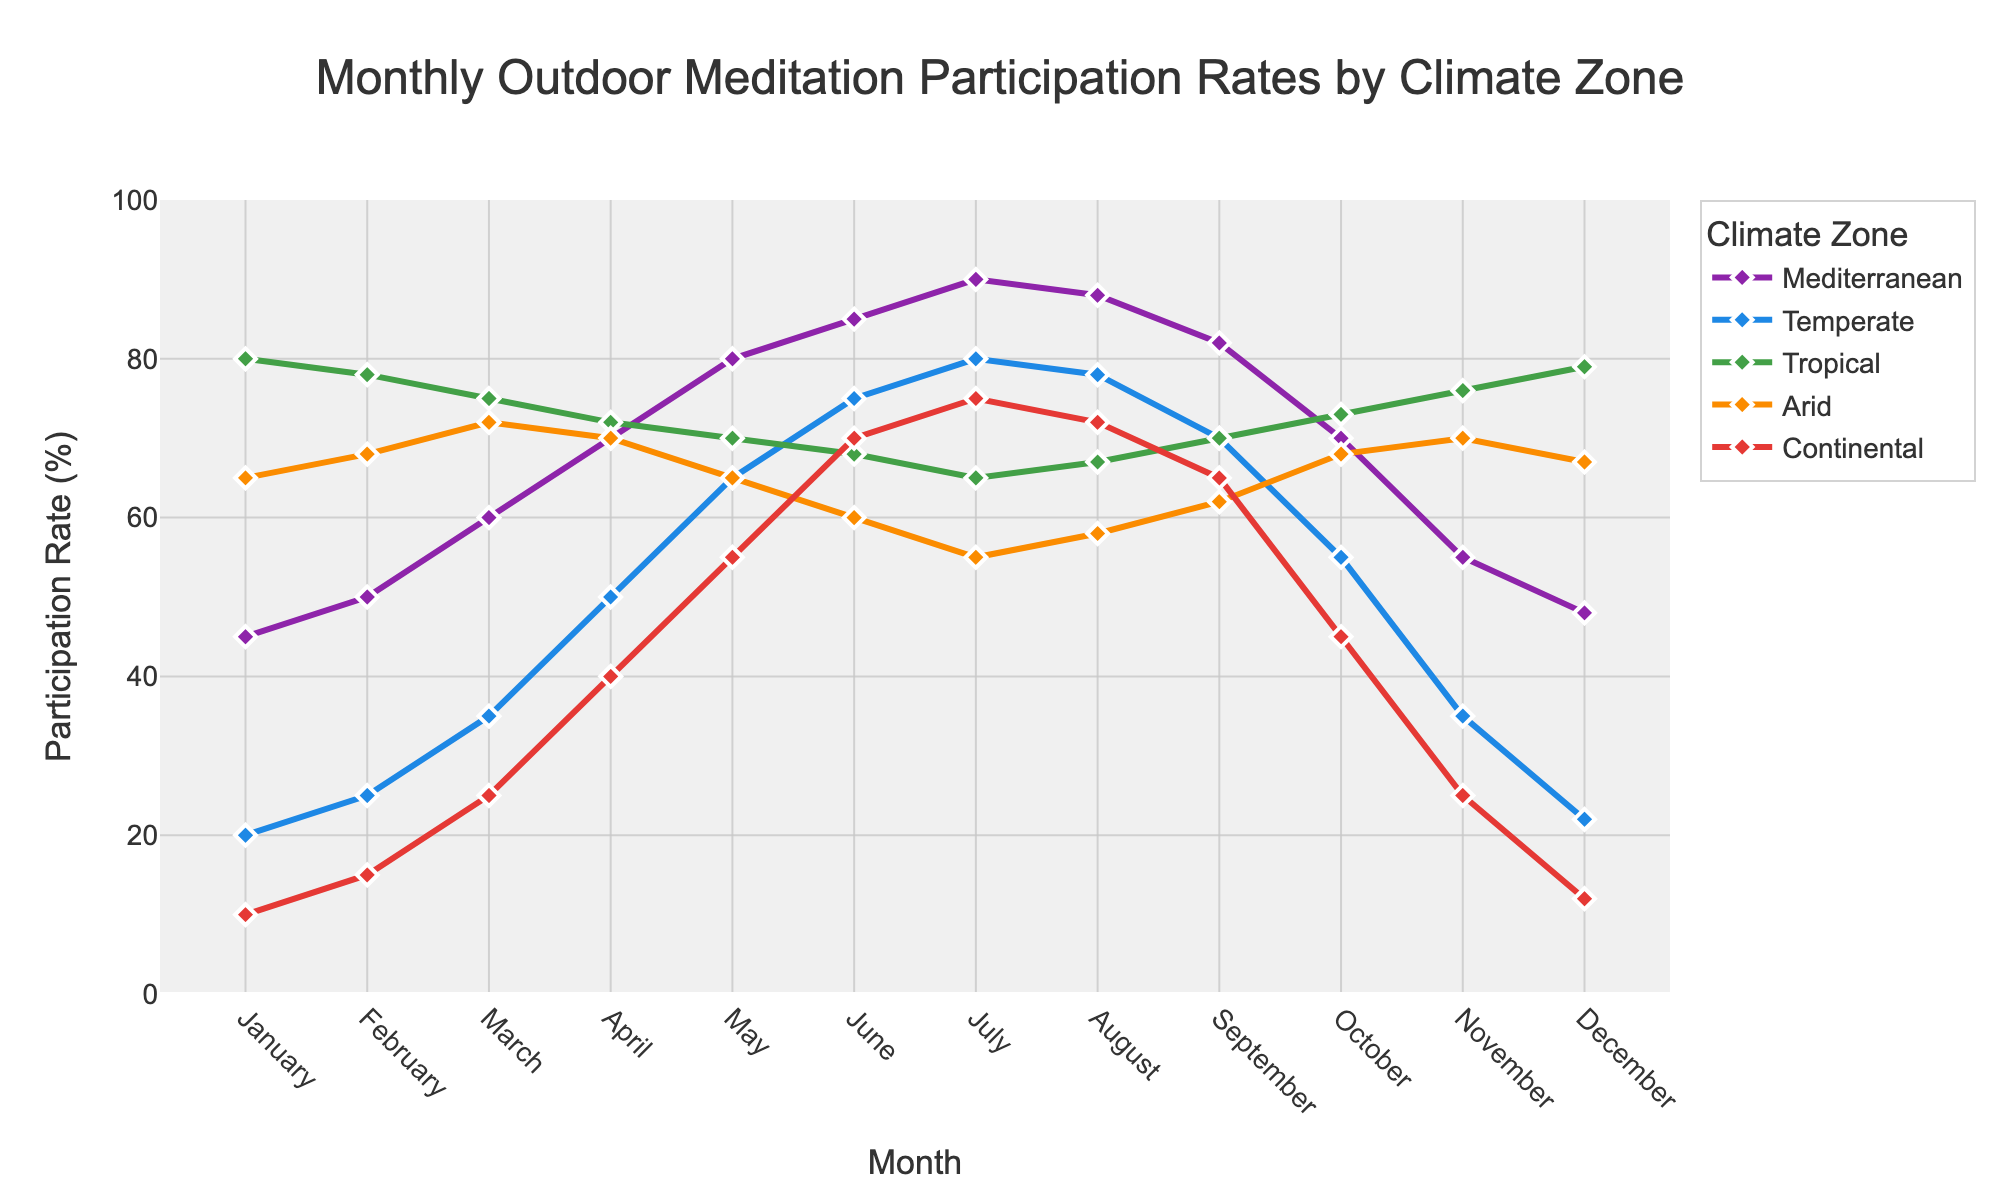What is the highest participation rate for the Mediterranean climate zone, and in which month does it occur? The Mediterranean climate zone reaches its highest participation rate in July at 90%. This is evident from the peak of the line for the Mediterranean zone, marked with a prominent point.
Answer: 90%, July Which climate zone has the lowest participation rate in January? In January, the line representing the Continental zone is at the lowest point compared to other zones, indicating the lowest participation rate of 10%.
Answer: Continental By how much does the participation rate in the Temperate zone increase from January to June? The participation rate in the Temperate zone in January is 20%, and it rises to 75% in June. The increment is 75% - 20% = 55%.
Answer: 55% What is the average participation rate for the Tropical zone over the first three months (January, February, March)? The participation rates for the Tropical zone in January, February, and March are 80%, 78%, and 75%, respectively. The average is (80 + 78 + 75) / 3 = 77.67%.
Answer: 77.67% In which month is the participation rate for the Arid zone equal to the participation rate for the Temperate zone? The line representing the participation rates for the Arid and Temperate zones intersect in April, both at 70%. This indicates the months where their rates are equal.
Answer: April What is the trend for the participation rate in the Temperate zone from January to December? The participation rate in the Temperate zone starts low in January, increases steadily until July where it peaks at 80%, and then decreases towards December.
Answer: Rising till July, then falling Compare the participation rates for the Continental zone in July to the Mediterranean zone in July. Which is higher and by how much? The participation rate for the Continental zone in July is 75%, while for the Mediterranean zone it is 90%. The Mediterranean rate is higher by 90% - 75% = 15%.
Answer: Mediterranean by 15% What is the participation rate for the Tropical zone in August, and how does it compare to the rate in June? The participation rate in the Tropical zone is 67% in August and 68% in June. The rate in August is 1% lower than in June.
Answer: 67%, 1% lower 